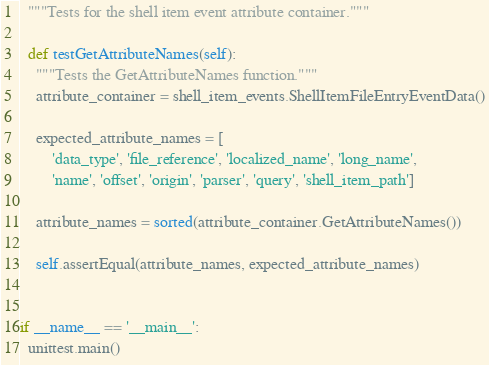Convert code to text. <code><loc_0><loc_0><loc_500><loc_500><_Python_>  """Tests for the shell item event attribute container."""

  def testGetAttributeNames(self):
    """Tests the GetAttributeNames function."""
    attribute_container = shell_item_events.ShellItemFileEntryEventData()

    expected_attribute_names = [
        'data_type', 'file_reference', 'localized_name', 'long_name',
        'name', 'offset', 'origin', 'parser', 'query', 'shell_item_path']

    attribute_names = sorted(attribute_container.GetAttributeNames())

    self.assertEqual(attribute_names, expected_attribute_names)


if __name__ == '__main__':
  unittest.main()
</code> 